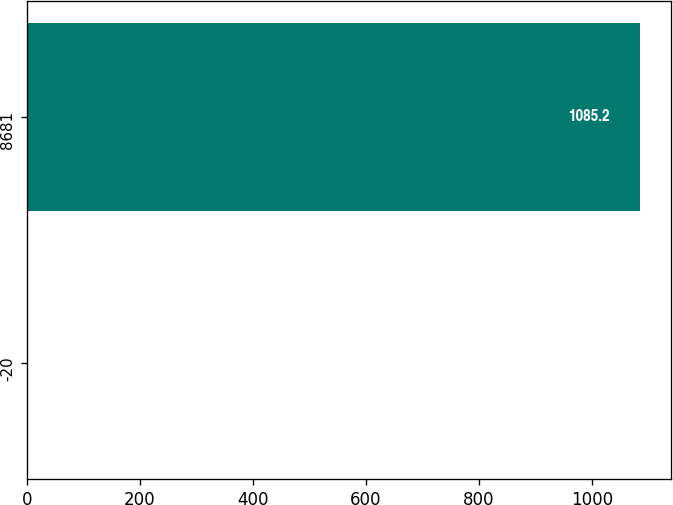Convert chart to OTSL. <chart><loc_0><loc_0><loc_500><loc_500><bar_chart><fcel>-20<fcel>8681<nl><fcel>1.28<fcel>1085.2<nl></chart> 